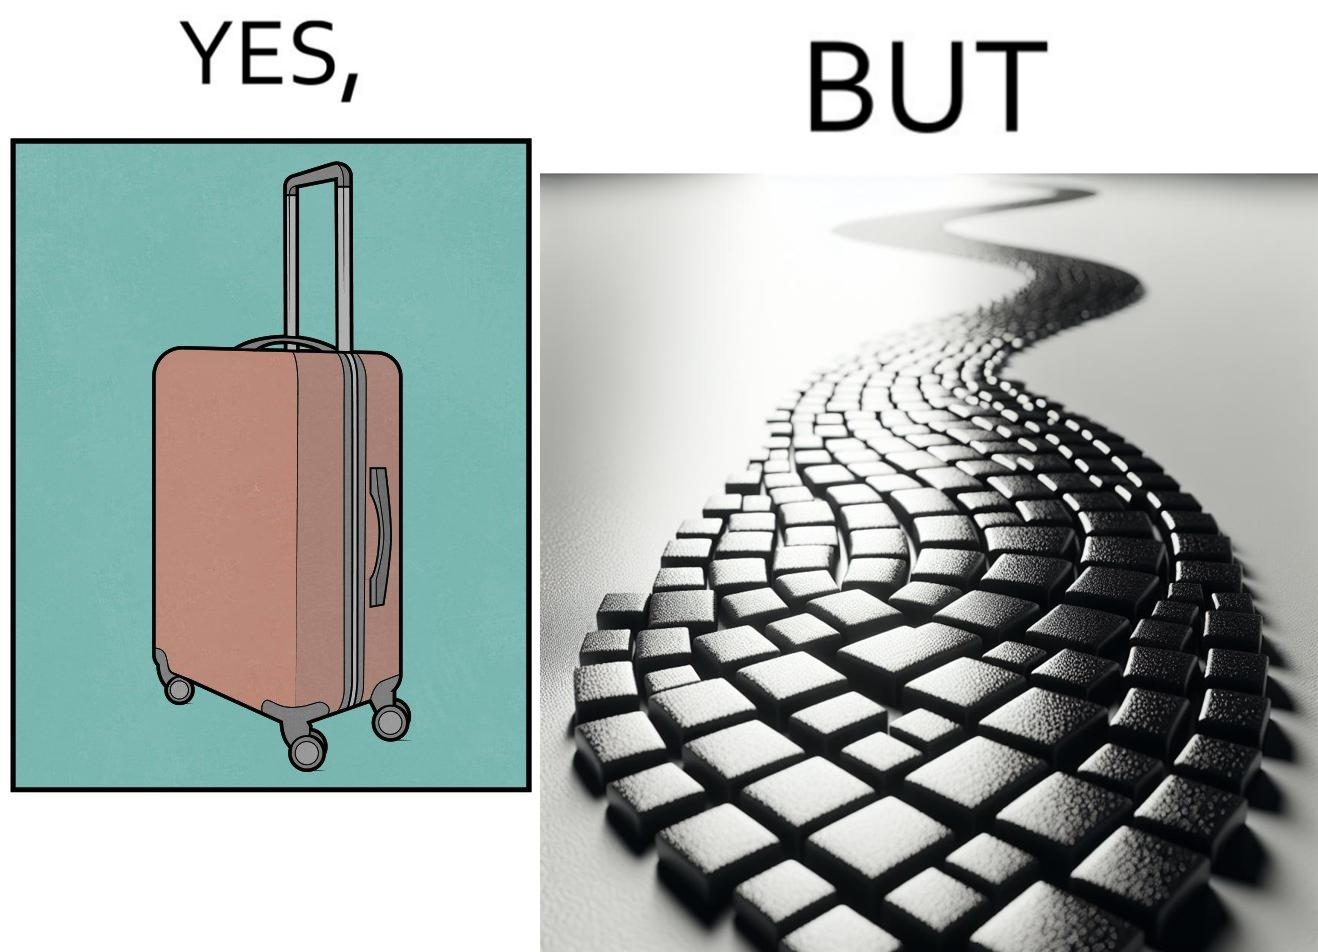Describe the satirical element in this image. The image is funny because even though the trolley bag is made to make carrying luggage easy, as soon as it encounters a rough surface like cobblestone road, it makes carrying luggage more difficult. 